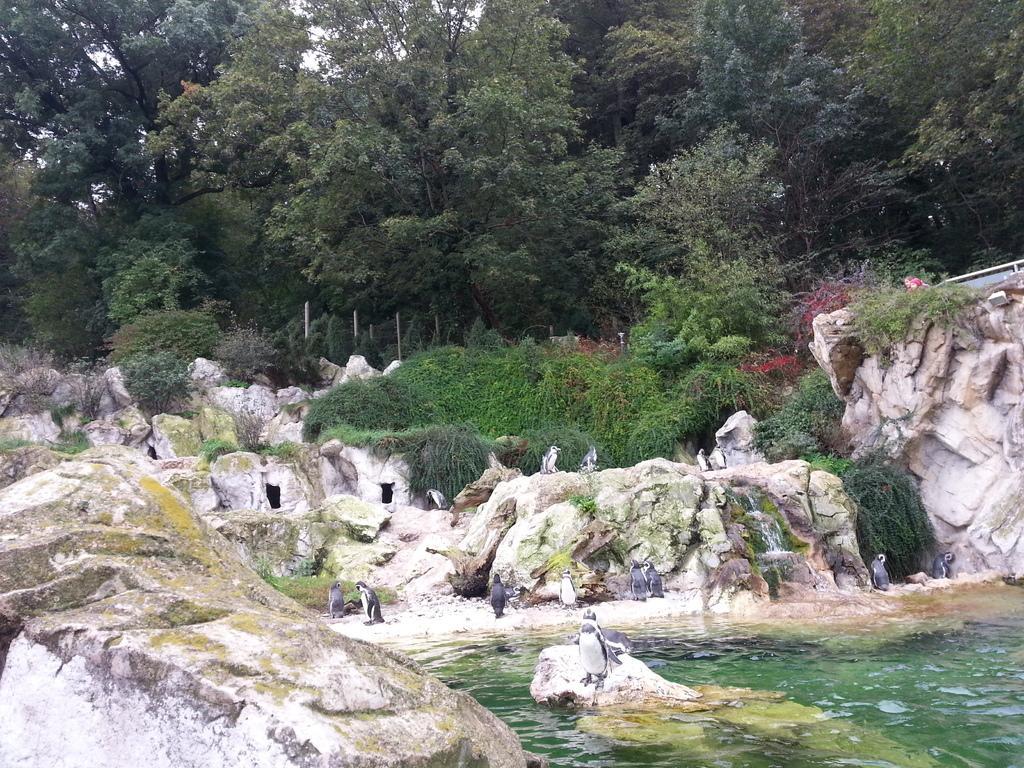In one or two sentences, can you explain what this image depicts? In this image I can see water in the front and in the center of this image I can see number of penguins. In the background I can see plants, few moles and number of trees. 